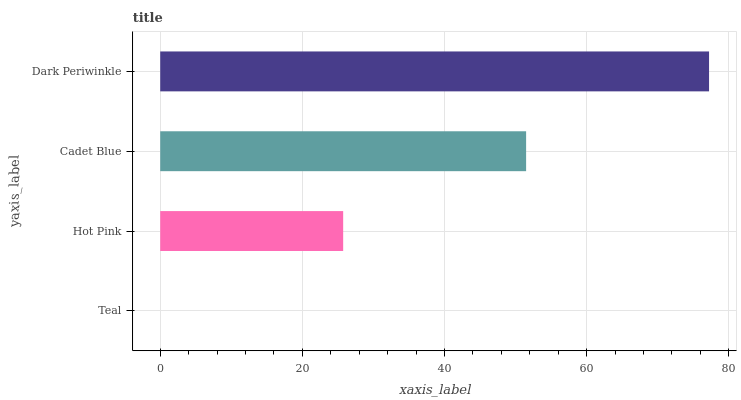Is Teal the minimum?
Answer yes or no. Yes. Is Dark Periwinkle the maximum?
Answer yes or no. Yes. Is Hot Pink the minimum?
Answer yes or no. No. Is Hot Pink the maximum?
Answer yes or no. No. Is Hot Pink greater than Teal?
Answer yes or no. Yes. Is Teal less than Hot Pink?
Answer yes or no. Yes. Is Teal greater than Hot Pink?
Answer yes or no. No. Is Hot Pink less than Teal?
Answer yes or no. No. Is Cadet Blue the high median?
Answer yes or no. Yes. Is Hot Pink the low median?
Answer yes or no. Yes. Is Teal the high median?
Answer yes or no. No. Is Teal the low median?
Answer yes or no. No. 